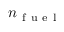<formula> <loc_0><loc_0><loc_500><loc_500>n _ { f u e l }</formula> 